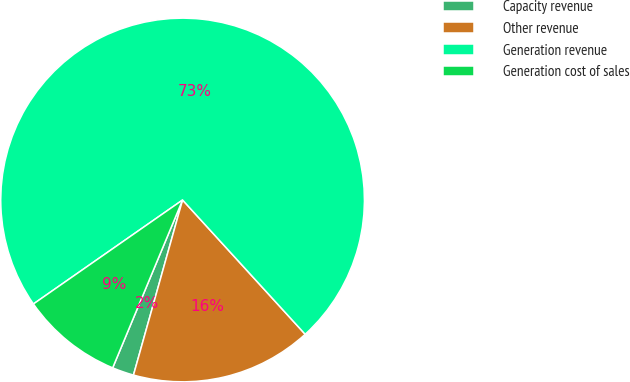Convert chart to OTSL. <chart><loc_0><loc_0><loc_500><loc_500><pie_chart><fcel>Capacity revenue<fcel>Other revenue<fcel>Generation revenue<fcel>Generation cost of sales<nl><fcel>1.93%<fcel>16.13%<fcel>72.92%<fcel>9.03%<nl></chart> 